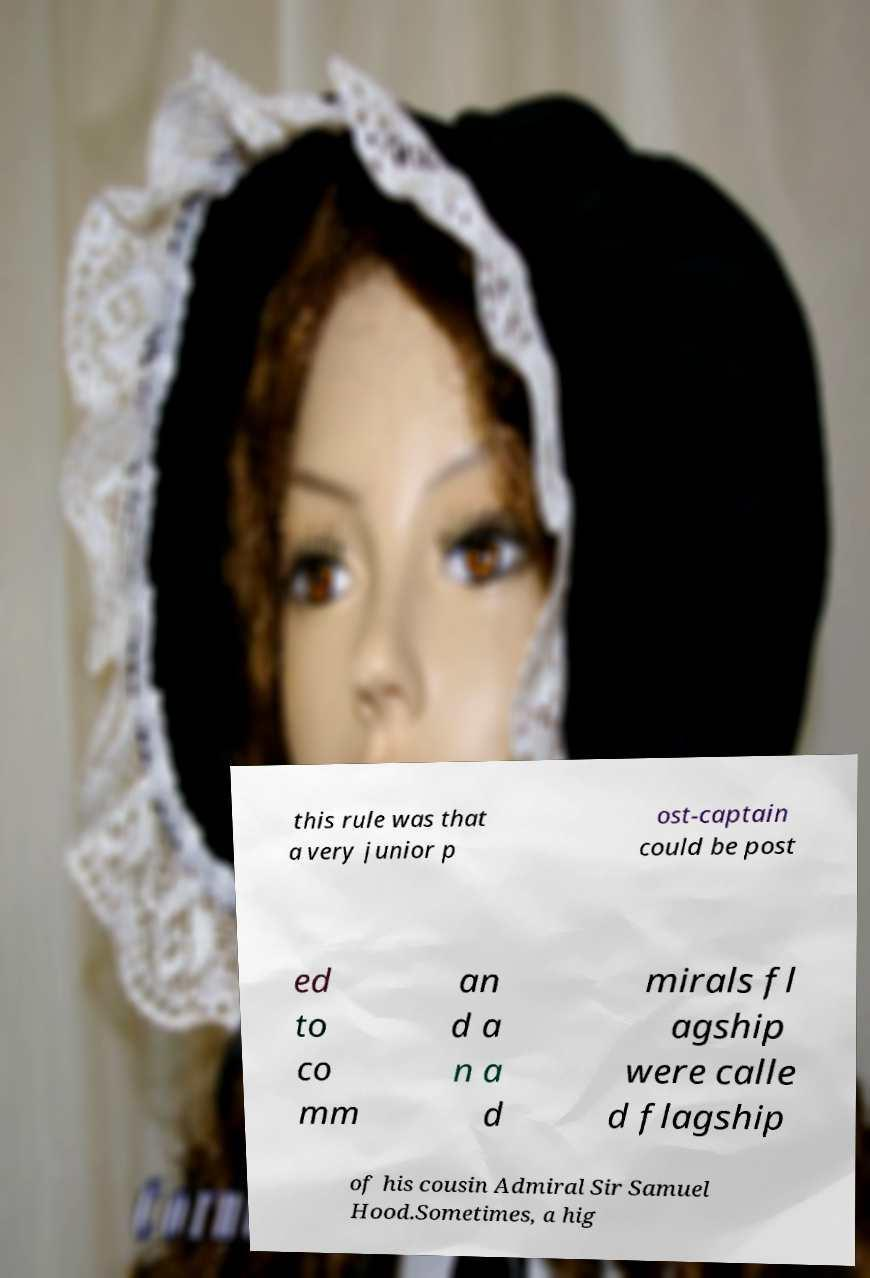Can you read and provide the text displayed in the image?This photo seems to have some interesting text. Can you extract and type it out for me? this rule was that a very junior p ost-captain could be post ed to co mm an d a n a d mirals fl agship were calle d flagship of his cousin Admiral Sir Samuel Hood.Sometimes, a hig 